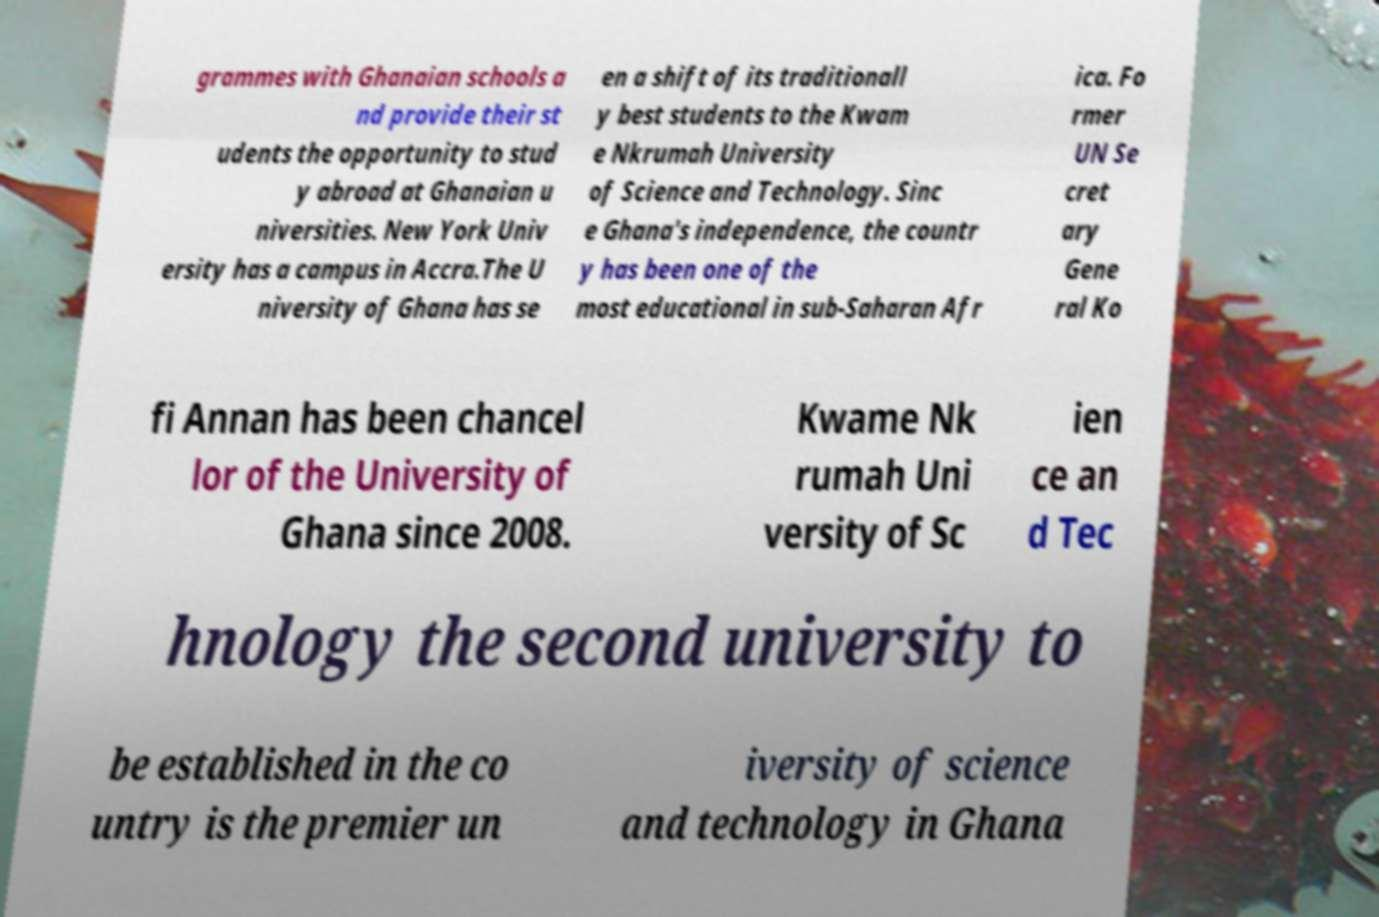Could you assist in decoding the text presented in this image and type it out clearly? grammes with Ghanaian schools a nd provide their st udents the opportunity to stud y abroad at Ghanaian u niversities. New York Univ ersity has a campus in Accra.The U niversity of Ghana has se en a shift of its traditionall y best students to the Kwam e Nkrumah University of Science and Technology. Sinc e Ghana's independence, the countr y has been one of the most educational in sub-Saharan Afr ica. Fo rmer UN Se cret ary Gene ral Ko fi Annan has been chancel lor of the University of Ghana since 2008. Kwame Nk rumah Uni versity of Sc ien ce an d Tec hnology the second university to be established in the co untry is the premier un iversity of science and technology in Ghana 